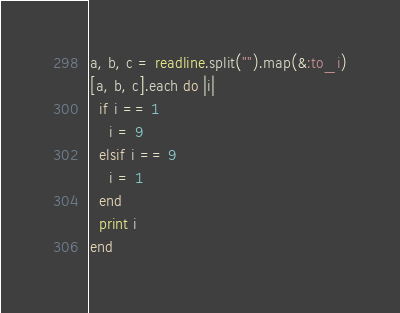<code> <loc_0><loc_0><loc_500><loc_500><_Ruby_>a, b, c = readline.split("").map(&:to_i)
[a, b, c].each do |i|
  if i == 1 
    i = 9 
  elsif i == 9 
    i = 1
  end
  print i
end</code> 